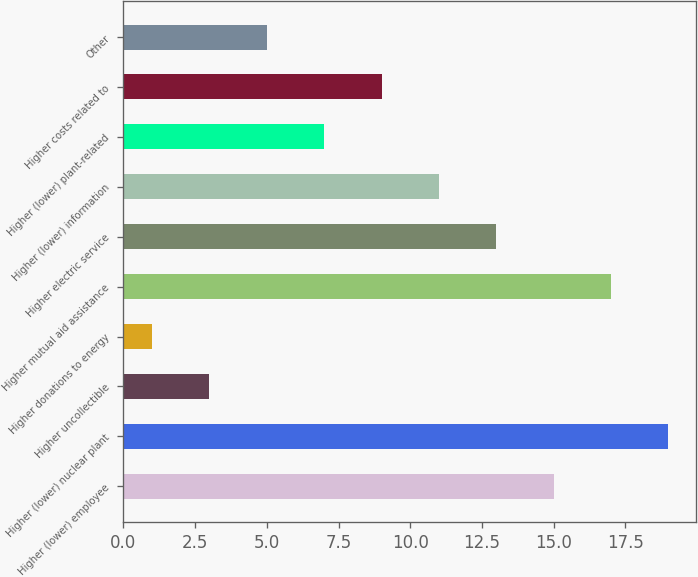<chart> <loc_0><loc_0><loc_500><loc_500><bar_chart><fcel>Higher (lower) employee<fcel>Higher (lower) nuclear plant<fcel>Higher uncollectible<fcel>Higher donations to energy<fcel>Higher mutual aid assistance<fcel>Higher electric service<fcel>Higher (lower) information<fcel>Higher (lower) plant-related<fcel>Higher costs related to<fcel>Other<nl><fcel>15<fcel>19<fcel>3<fcel>1<fcel>17<fcel>13<fcel>11<fcel>7<fcel>9<fcel>5<nl></chart> 